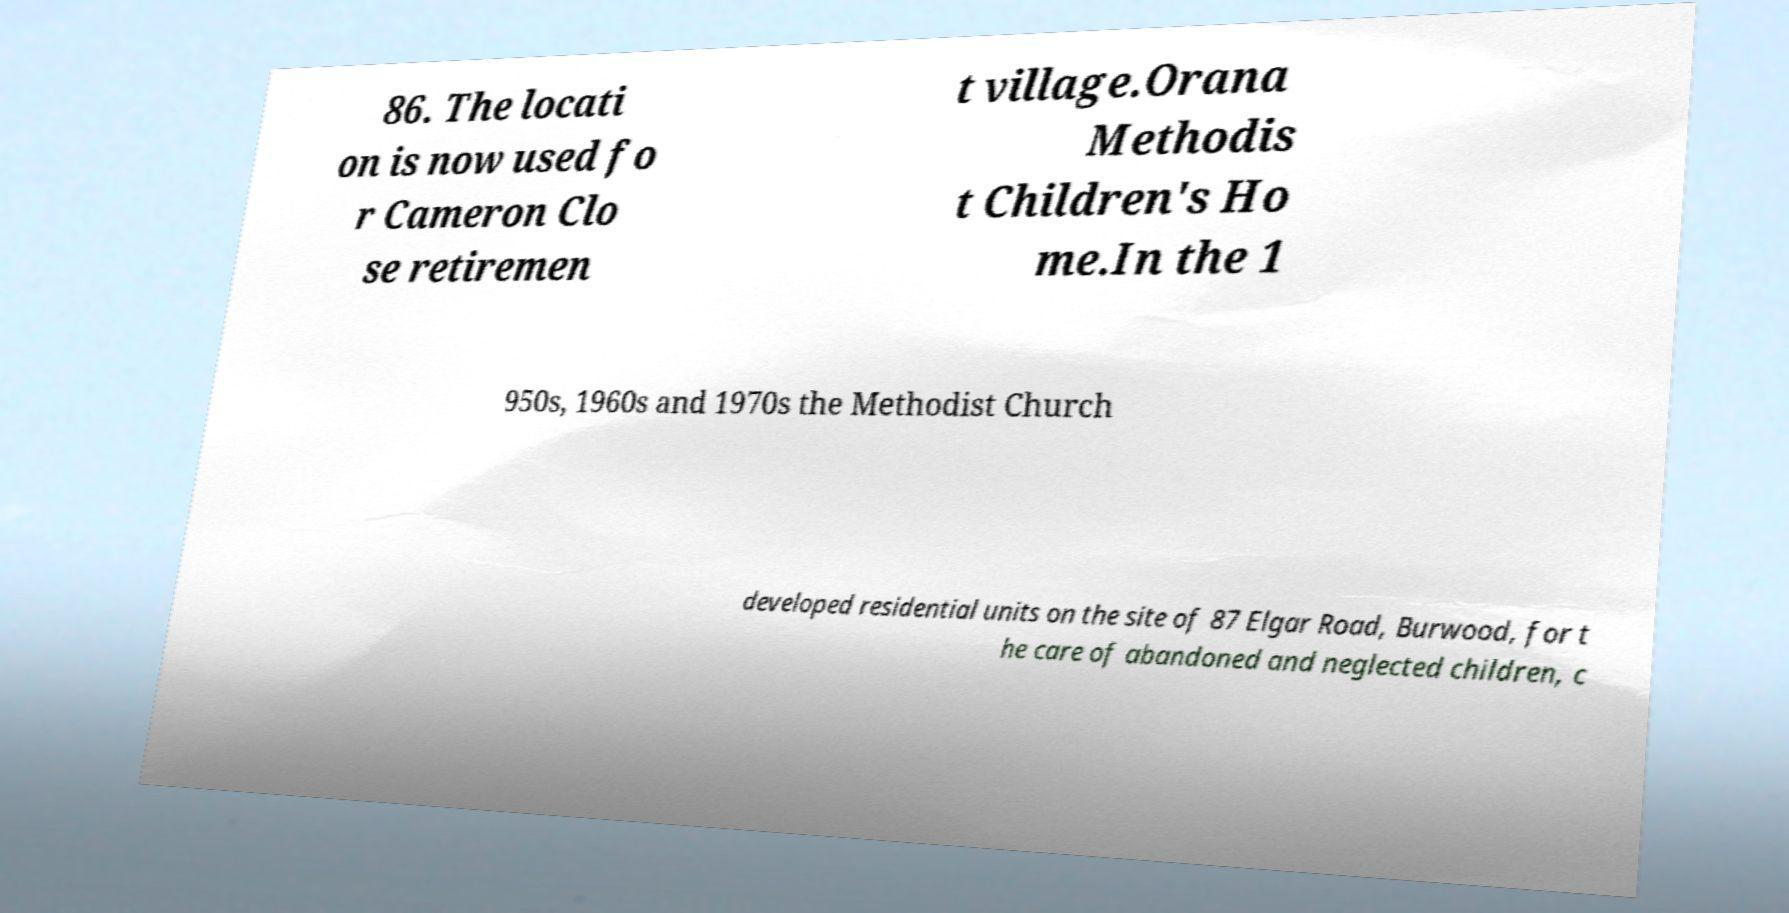What messages or text are displayed in this image? I need them in a readable, typed format. 86. The locati on is now used fo r Cameron Clo se retiremen t village.Orana Methodis t Children's Ho me.In the 1 950s, 1960s and 1970s the Methodist Church developed residential units on the site of 87 Elgar Road, Burwood, for t he care of abandoned and neglected children, c 